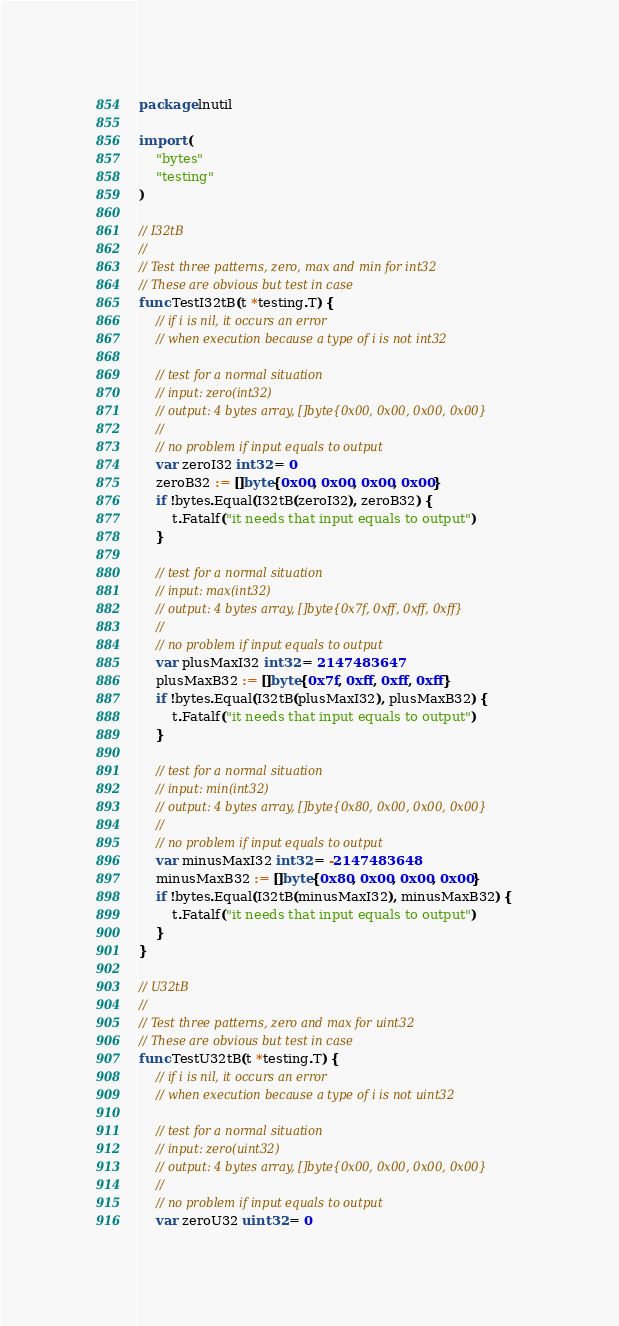<code> <loc_0><loc_0><loc_500><loc_500><_Go_>package lnutil

import (
	"bytes"
	"testing"
)

// I32tB
//
// Test three patterns, zero, max and min for int32
// These are obvious but test in case
func TestI32tB(t *testing.T) {
	// if i is nil, it occurs an error
	// when execution because a type of i is not int32

	// test for a normal situation
	// input: zero(int32)
	// output: 4 bytes array, []byte{0x00, 0x00, 0x00, 0x00}
	//
	// no problem if input equals to output
	var zeroI32 int32 = 0
	zeroB32 := []byte{0x00, 0x00, 0x00, 0x00}
	if !bytes.Equal(I32tB(zeroI32), zeroB32) {
		t.Fatalf("it needs that input equals to output")
	}

	// test for a normal situation
	// input: max(int32)
	// output: 4 bytes array, []byte{0x7f, 0xff, 0xff, 0xff}
	//
	// no problem if input equals to output
	var plusMaxI32 int32 = 2147483647
	plusMaxB32 := []byte{0x7f, 0xff, 0xff, 0xff}
	if !bytes.Equal(I32tB(plusMaxI32), plusMaxB32) {
		t.Fatalf("it needs that input equals to output")
	}

	// test for a normal situation
	// input: min(int32)
	// output: 4 bytes array, []byte{0x80, 0x00, 0x00, 0x00}
	//
	// no problem if input equals to output
	var minusMaxI32 int32 = -2147483648
	minusMaxB32 := []byte{0x80, 0x00, 0x00, 0x00}
	if !bytes.Equal(I32tB(minusMaxI32), minusMaxB32) {
		t.Fatalf("it needs that input equals to output")
	}
}

// U32tB
//
// Test three patterns, zero and max for uint32
// These are obvious but test in case
func TestU32tB(t *testing.T) {
	// if i is nil, it occurs an error
	// when execution because a type of i is not uint32

	// test for a normal situation
	// input: zero(uint32)
	// output: 4 bytes array, []byte{0x00, 0x00, 0x00, 0x00}
	//
	// no problem if input equals to output
	var zeroU32 uint32 = 0</code> 